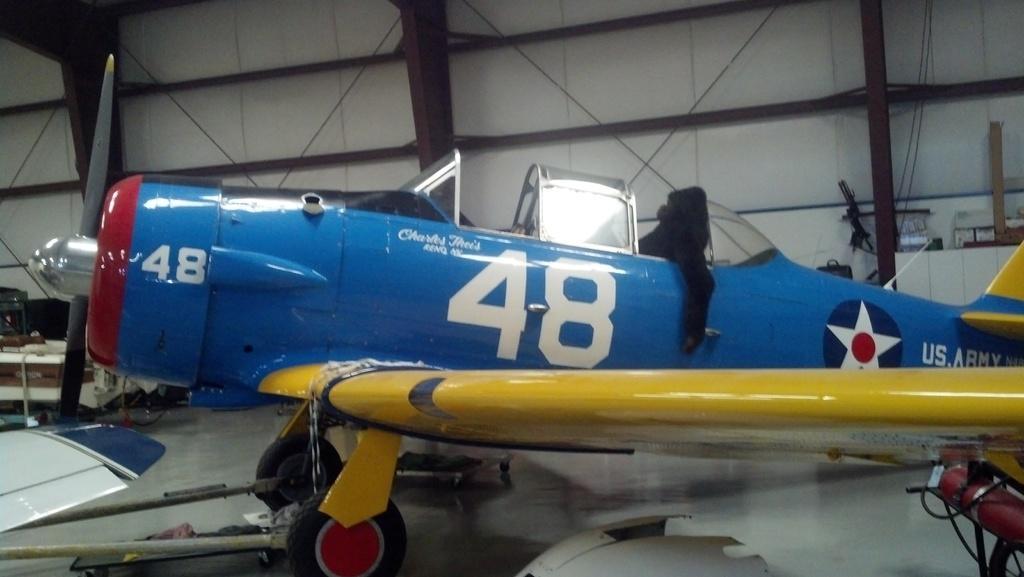Could you give a brief overview of what you see in this image? In this image in the center it looks like an aircraft, and in the background there are some poles and some wires. At the bottom there is floor and in the background there are some other objects, and also i can see some wires on the right side. 